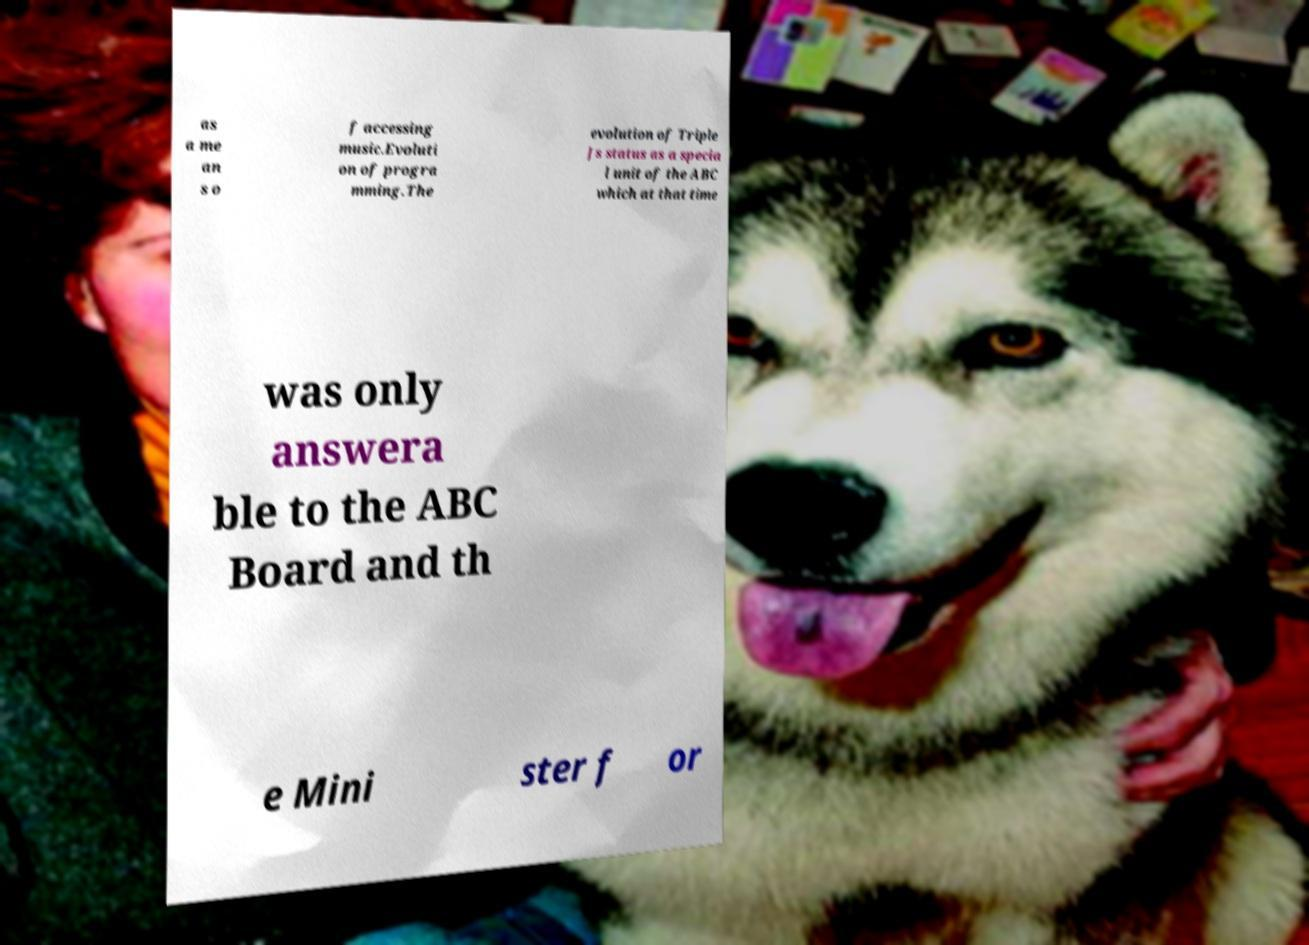Please read and relay the text visible in this image. What does it say? as a me an s o f accessing music.Evoluti on of progra mming.The evolution of Triple Js status as a specia l unit of the ABC which at that time was only answera ble to the ABC Board and th e Mini ster f or 